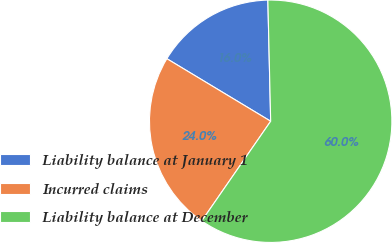Convert chart. <chart><loc_0><loc_0><loc_500><loc_500><pie_chart><fcel>Liability balance at January 1<fcel>Incurred claims<fcel>Liability balance at December<nl><fcel>16.0%<fcel>24.0%<fcel>60.0%<nl></chart> 